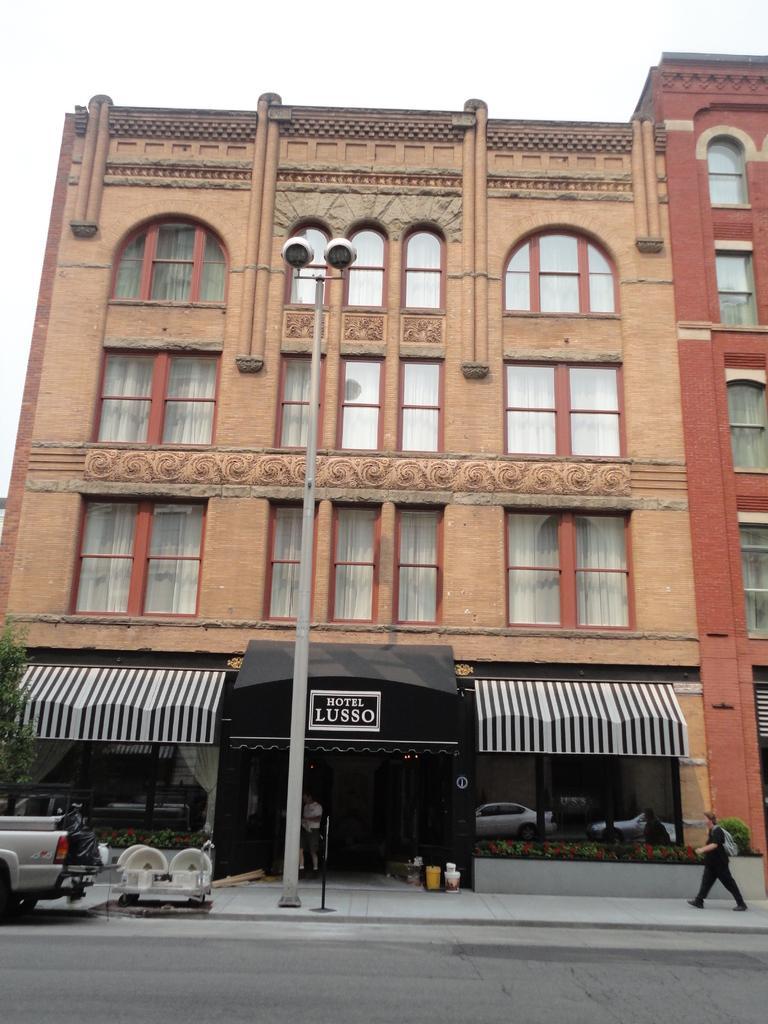Describe this image in one or two sentences. In this image, we can see a building, there are some windows on the building, there is a pole, we can see a person walking, there is a car, at the top we can see the sky. 